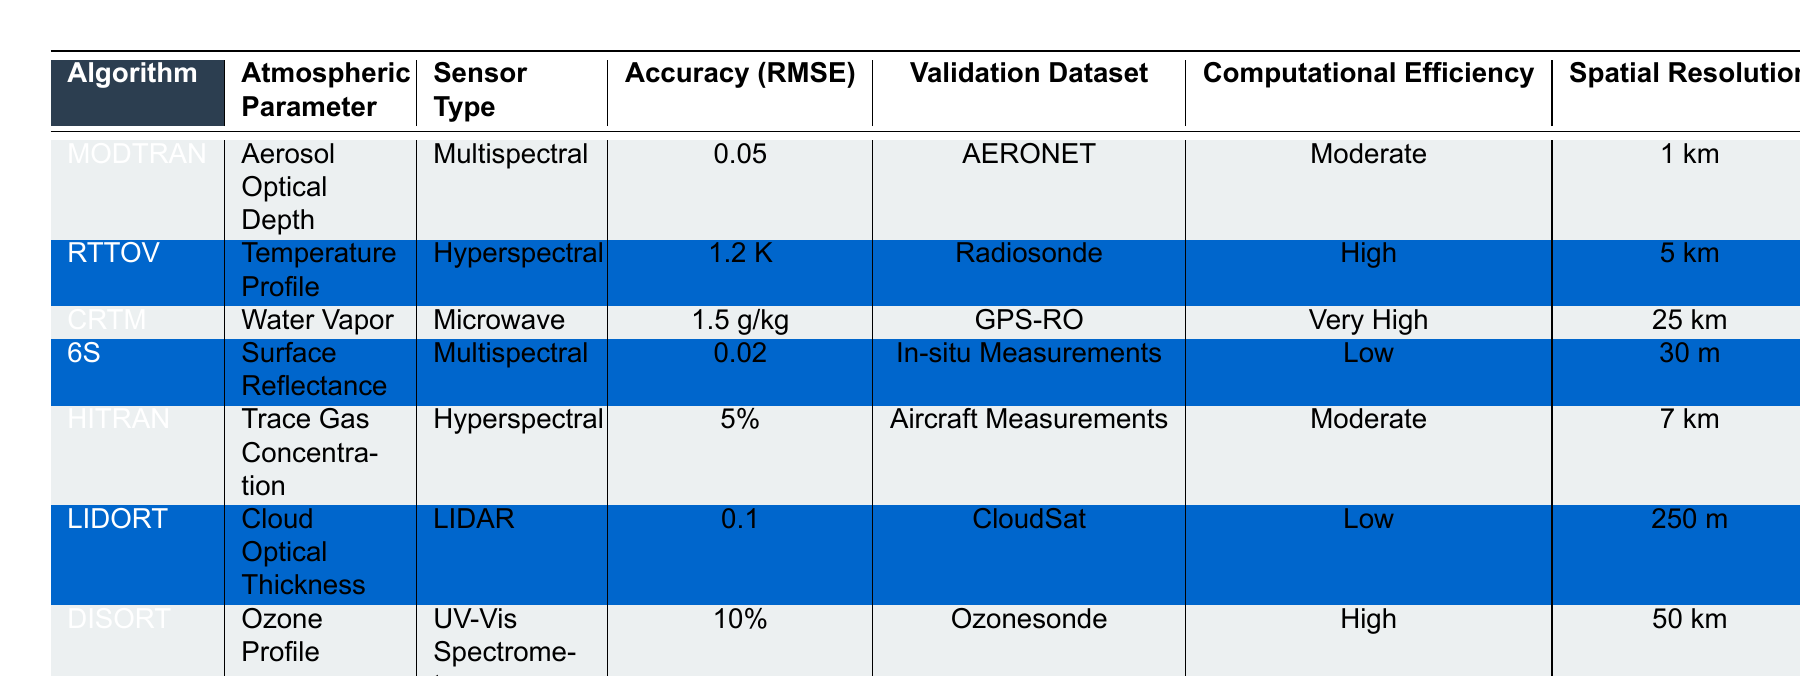What is the accuracy (RMSE) of the 6S algorithm? According to the table, the accuracy (RMSE) for the 6S algorithm is listed as 0.02.
Answer: 0.02 Which algorithm has the highest computational efficiency? The table indicates that the CRTM algorithm has the highest computational efficiency rated as "Very High."
Answer: CRTM Is the accuracy of the MODTRAN algorithm better than that of the HITRAN algorithm? By comparing the RMSE values in the table, the MODTRAN has an RMSE of 0.05, while HITRAN has an accuracy of 5%. Since 0.05 is numerically better than 5%, MODTRAN's accuracy is better.
Answer: Yes What is the spatial resolution of the LIDORT algorithm? By referencing the table, the spatial resolution for the LIDORT algorithm is 250 m.
Answer: 250 m Which atmospheric parameter does the RTTOV algorithm measure, and what is its validation dataset? The RTTOV algorithm measures the Temperature Profile, and its validation dataset is from Radiosonde.
Answer: Temperature Profile, Radiosonde If you wanted to use an algorithm with high computational efficiency to retrieve Water Vapor, which algorithm would you choose? The table shows that the only high computational efficiency algorithm for Water Vapor is CRTM, which is rated as "Very High" in computational efficiency while measuring Water Vapor.
Answer: CRTM What is the average accuracy (RMSE) for the algorithms using Multispectral sensors? To find the average RMSE for the Multispectral algorithms (MODTRAN and 6S), calculate (0.05 + 0.02) / 2 = 0.035.
Answer: 0.035 Is there any algorithm listed that has a spatial resolution of 1 km or better? The table reveals that only MODTRAN meets this criterion with a spatial resolution of 1 km, while all others have resolutions greater than that.
Answer: Yes Which algorithm exhibits the lowest accuracy (RMSE) among all listed? According to the table, the 6S algorithm exhibits the lowest accuracy (RMSE) of 0.02, which is better than all the others.
Answer: 0.02 How many algorithms are listed that have a spatial resolution worse than 50 km? By analyzing the table, both CRTM (25 km) and RTTOV (5 km) are better than 50 km in spatial resolution, while DISORT (50 km) is exactly 50 km. Thus, only LIDORT (250 m) and HITRAN (7 km) are worse than 50 km.
Answer: 2 